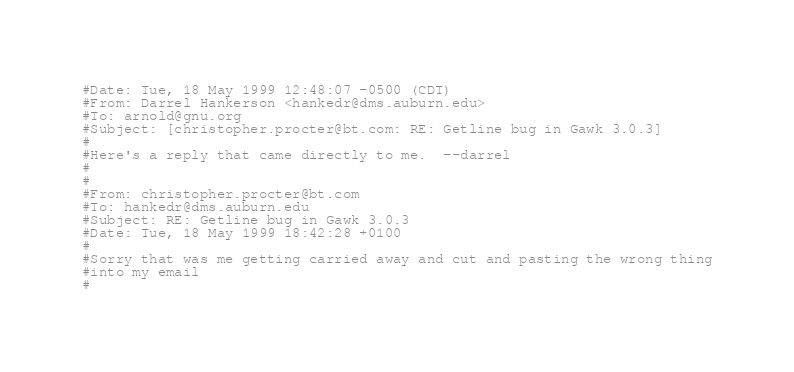<code> <loc_0><loc_0><loc_500><loc_500><_Awk_>#Date: Tue, 18 May 1999 12:48:07 -0500 (CDT)
#From: Darrel Hankerson <hankedr@dms.auburn.edu>
#To: arnold@gnu.org
#Subject: [christopher.procter@bt.com: RE: Getline bug in Gawk 3.0.3]
#
#Here's a reply that came directly to me.  --darrel
#
#
#From: christopher.procter@bt.com
#To: hankedr@dms.auburn.edu
#Subject: RE: Getline bug in Gawk 3.0.3
#Date: Tue, 18 May 1999 18:42:28 +0100
#
#Sorry that was me getting carried away and cut and pasting the wrong thing
#into my email
#</code> 